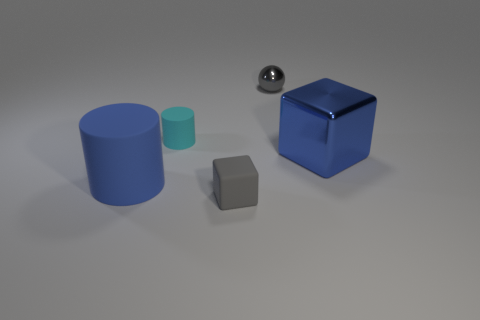There is a large blue cylinder; what number of tiny objects are behind it?
Keep it short and to the point. 2. Are the small gray object in front of the tiny cyan thing and the large thing on the left side of the gray metallic thing made of the same material?
Your answer should be compact. Yes. There is a large blue object that is on the left side of the cube in front of the blue object on the right side of the gray matte object; what is its shape?
Your response must be concise. Cylinder. The small metallic thing is what shape?
Keep it short and to the point. Sphere. The gray metallic object that is the same size as the matte block is what shape?
Your answer should be compact. Sphere. How many other things are the same color as the big matte object?
Your response must be concise. 1. There is a tiny thing in front of the blue block; is its shape the same as the blue object to the left of the small gray shiny ball?
Your answer should be very brief. No. What number of objects are either large cubes that are right of the big blue matte cylinder or things on the left side of the rubber cube?
Offer a very short reply. 3. What number of other things are the same material as the large blue cube?
Offer a terse response. 1. Does the cube right of the gray matte thing have the same material as the small gray cube?
Offer a terse response. No. 